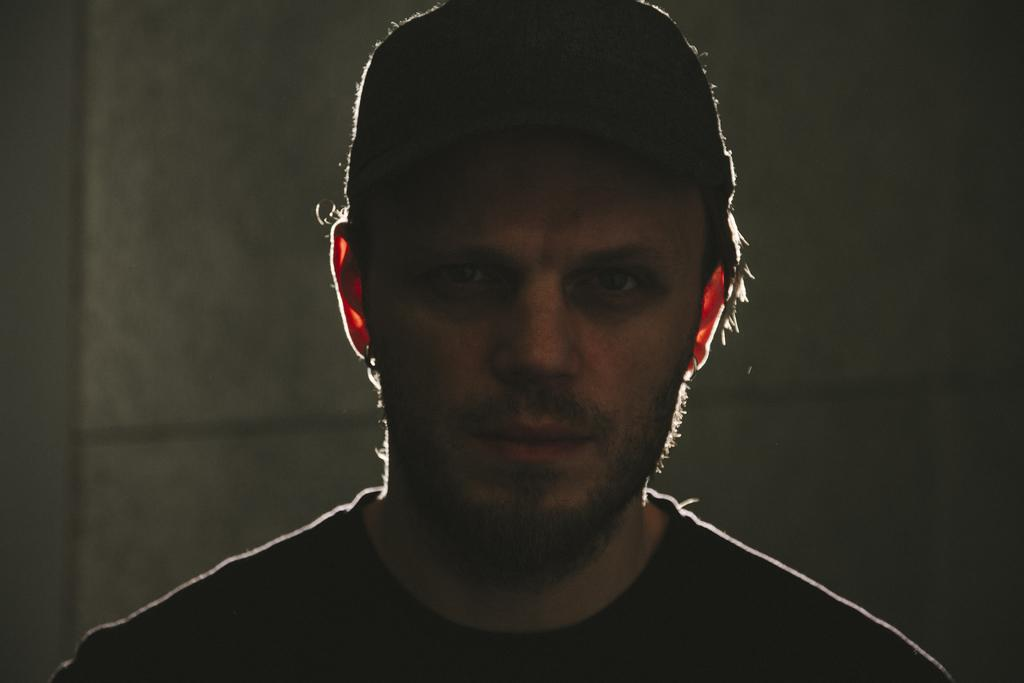What is the main subject of the image? There is a man in the image. How much of the man is visible in the image? Only the head of the man is visible in the image. Can you describe the background of the image? The background of the man is blurred. How many ladybugs can be seen on the man's head in the image? There are no ladybugs present on the man's head in the image. What type of credit is the man holding in the image? There is no credit visible in the image, as it only shows the man's head. 